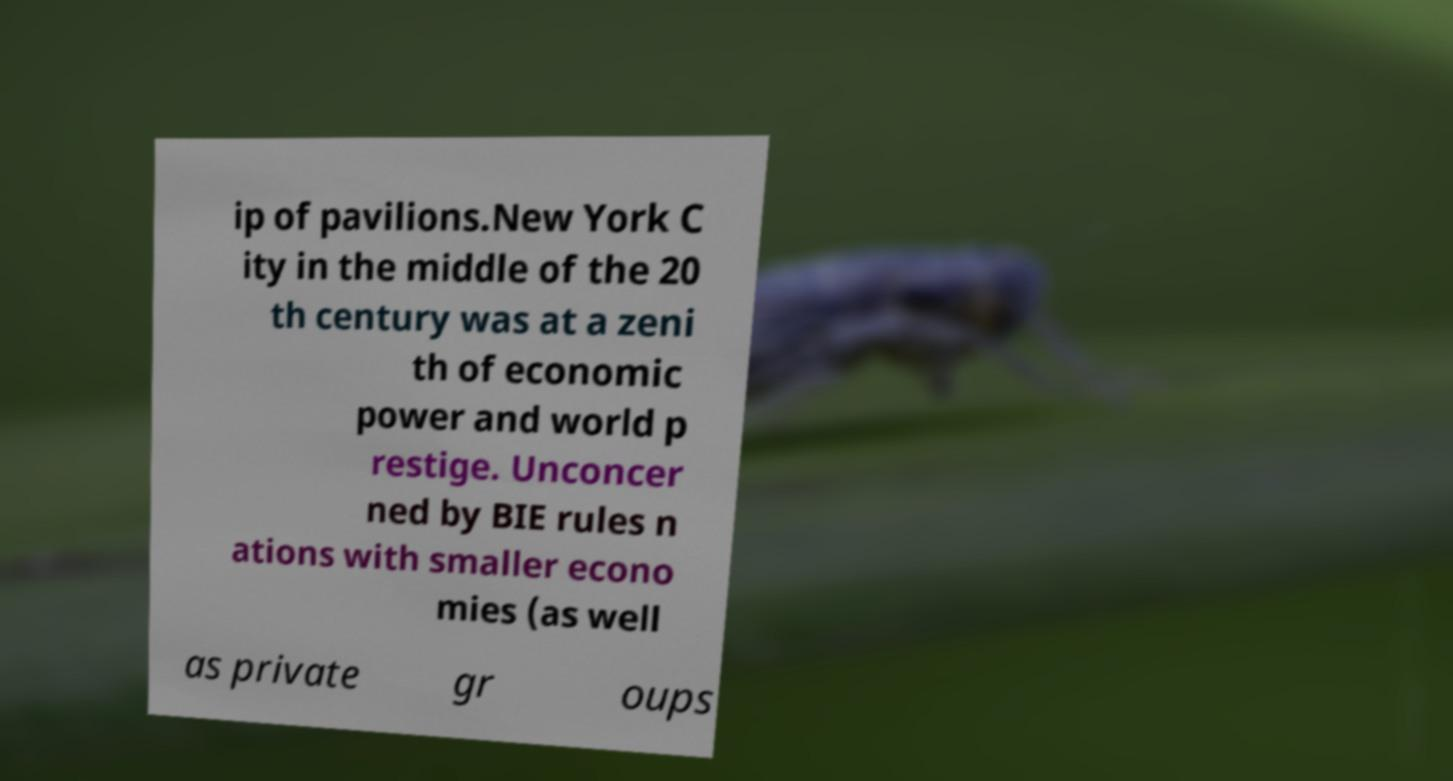I need the written content from this picture converted into text. Can you do that? ip of pavilions.New York C ity in the middle of the 20 th century was at a zeni th of economic power and world p restige. Unconcer ned by BIE rules n ations with smaller econo mies (as well as private gr oups 